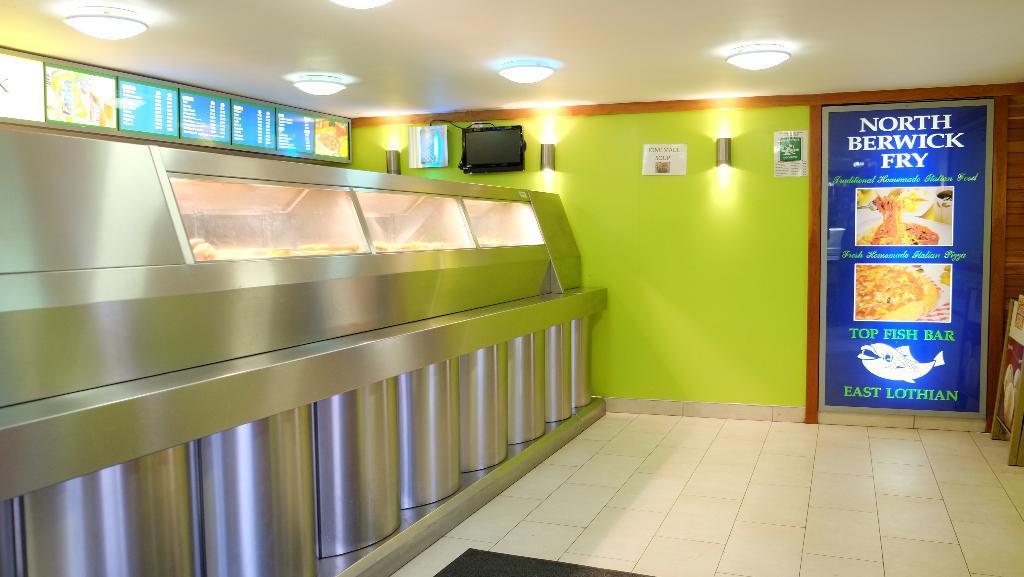In one or two sentences, can you explain what this image depicts? In this image we can see an inside view of a shop, there is an object towards the bottom of the image, there are boards, there is text on the boards, there is the wall, there is food, there are objects on the wall, there is a door, there is text on the door, there is an object towards the right of the image, there is roof towards the top of the image, there are lights. 